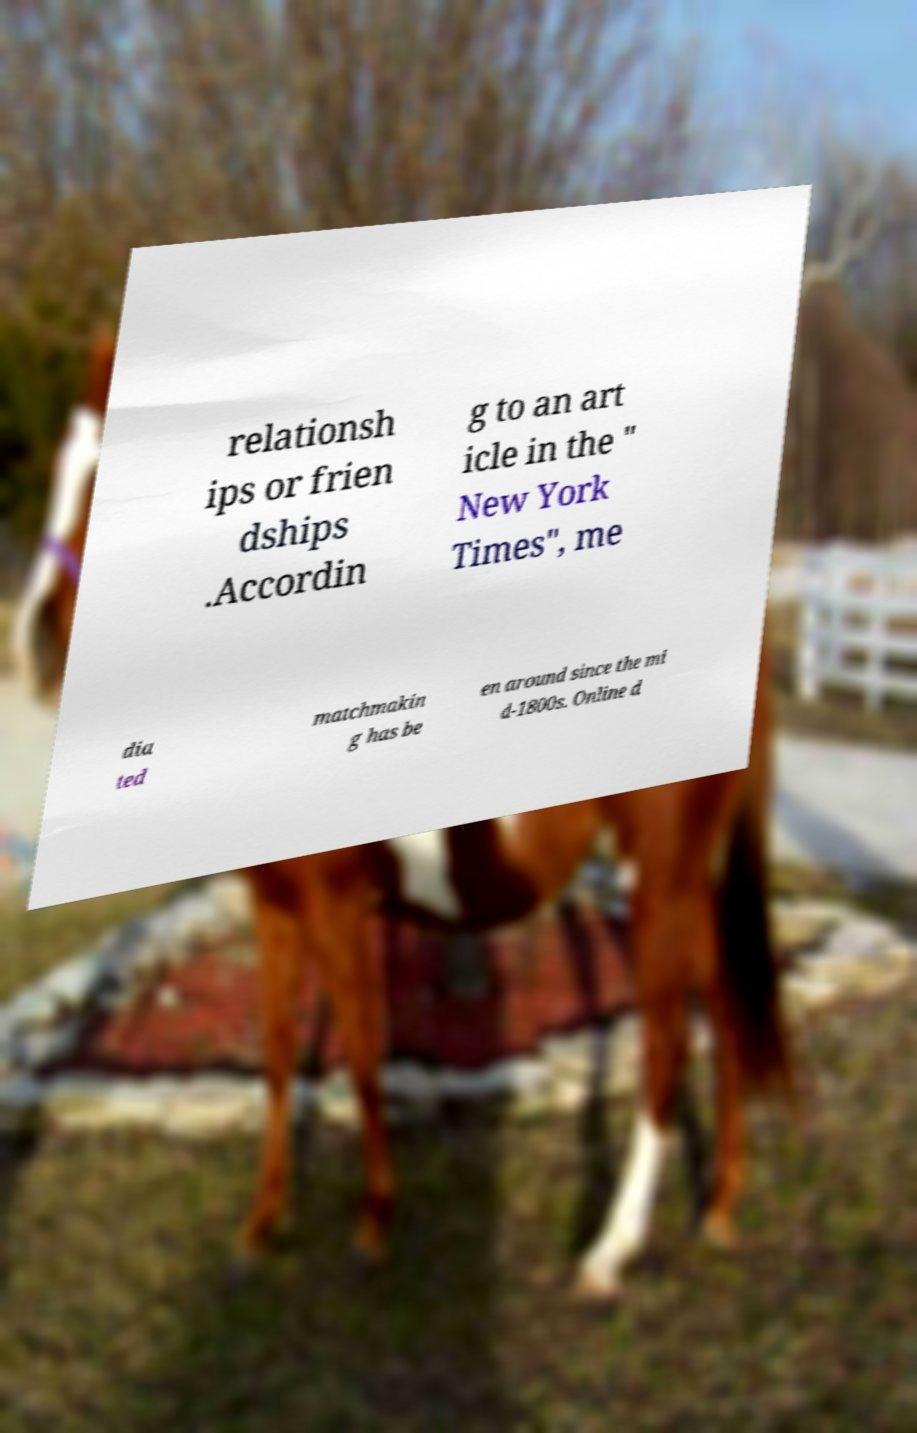I need the written content from this picture converted into text. Can you do that? relationsh ips or frien dships .Accordin g to an art icle in the " New York Times", me dia ted matchmakin g has be en around since the mi d-1800s. Online d 